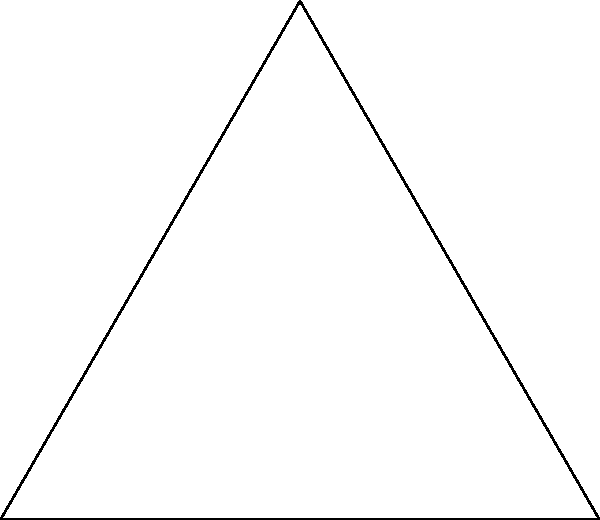In a football-shaped pitch (an equilateral triangle with an inscribed circle), the side length is 100 meters. Calculate the radius of the inscribed circle, assuming it's not the Queen of the South's home ground. Let's approach this step-by-step:

1) In an equilateral triangle, we can split it into two right triangles by drawing a line from a vertex to the midpoint of the opposite side.

2) Let $a$ be the side length of the equilateral triangle, $h$ be the height, and $r$ be the radius of the inscribed circle.

3) We know $a = 100$ meters.

4) In a right triangle formed by the height:
   $\cos 30° = \frac{\frac{a}{2}}{h}$
   $\frac{\sqrt{3}}{2} = \frac{50}{h}$
   $h = \frac{100}{\sqrt{3}} = 50\sqrt{3}$ meters

5) The radius of the inscribed circle is related to the area and perimeter of the triangle:
   $r = \frac{Area}{Semiperimeter} = \frac{\frac{1}{2}ah}{(3a)/2}$

6) Substituting the values:
   $r = \frac{\frac{1}{2} \cdot 100 \cdot 50\sqrt{3}}{150} = \frac{2500\sqrt{3}}{150}$

7) Simplifying:
   $r = \frac{50\sqrt{3}}{3} \approx 28.87$ meters
Answer: $\frac{50\sqrt{3}}{3}$ meters 